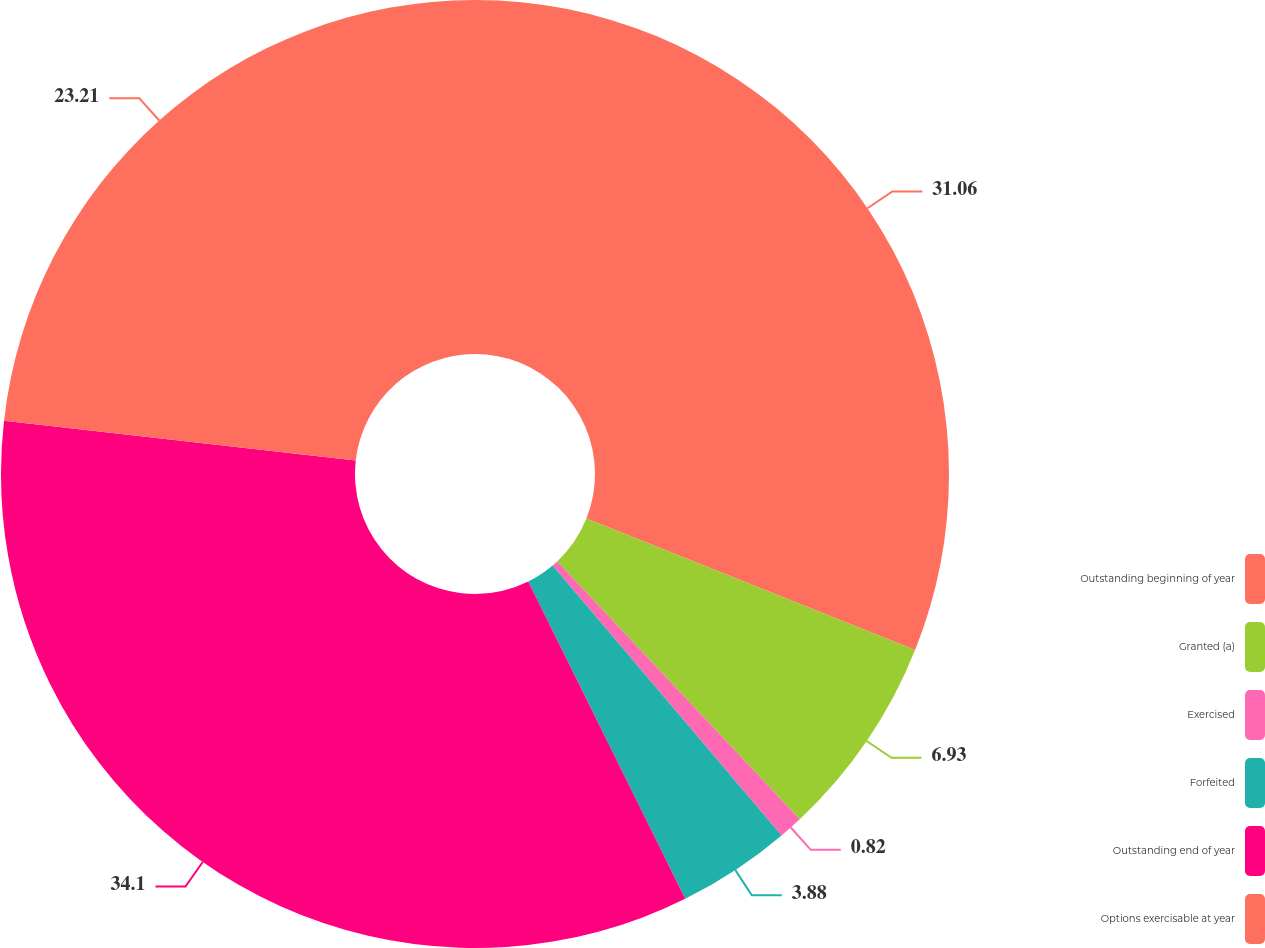Convert chart to OTSL. <chart><loc_0><loc_0><loc_500><loc_500><pie_chart><fcel>Outstanding beginning of year<fcel>Granted (a)<fcel>Exercised<fcel>Forfeited<fcel>Outstanding end of year<fcel>Options exercisable at year<nl><fcel>31.06%<fcel>6.93%<fcel>0.82%<fcel>3.88%<fcel>34.11%<fcel>23.21%<nl></chart> 